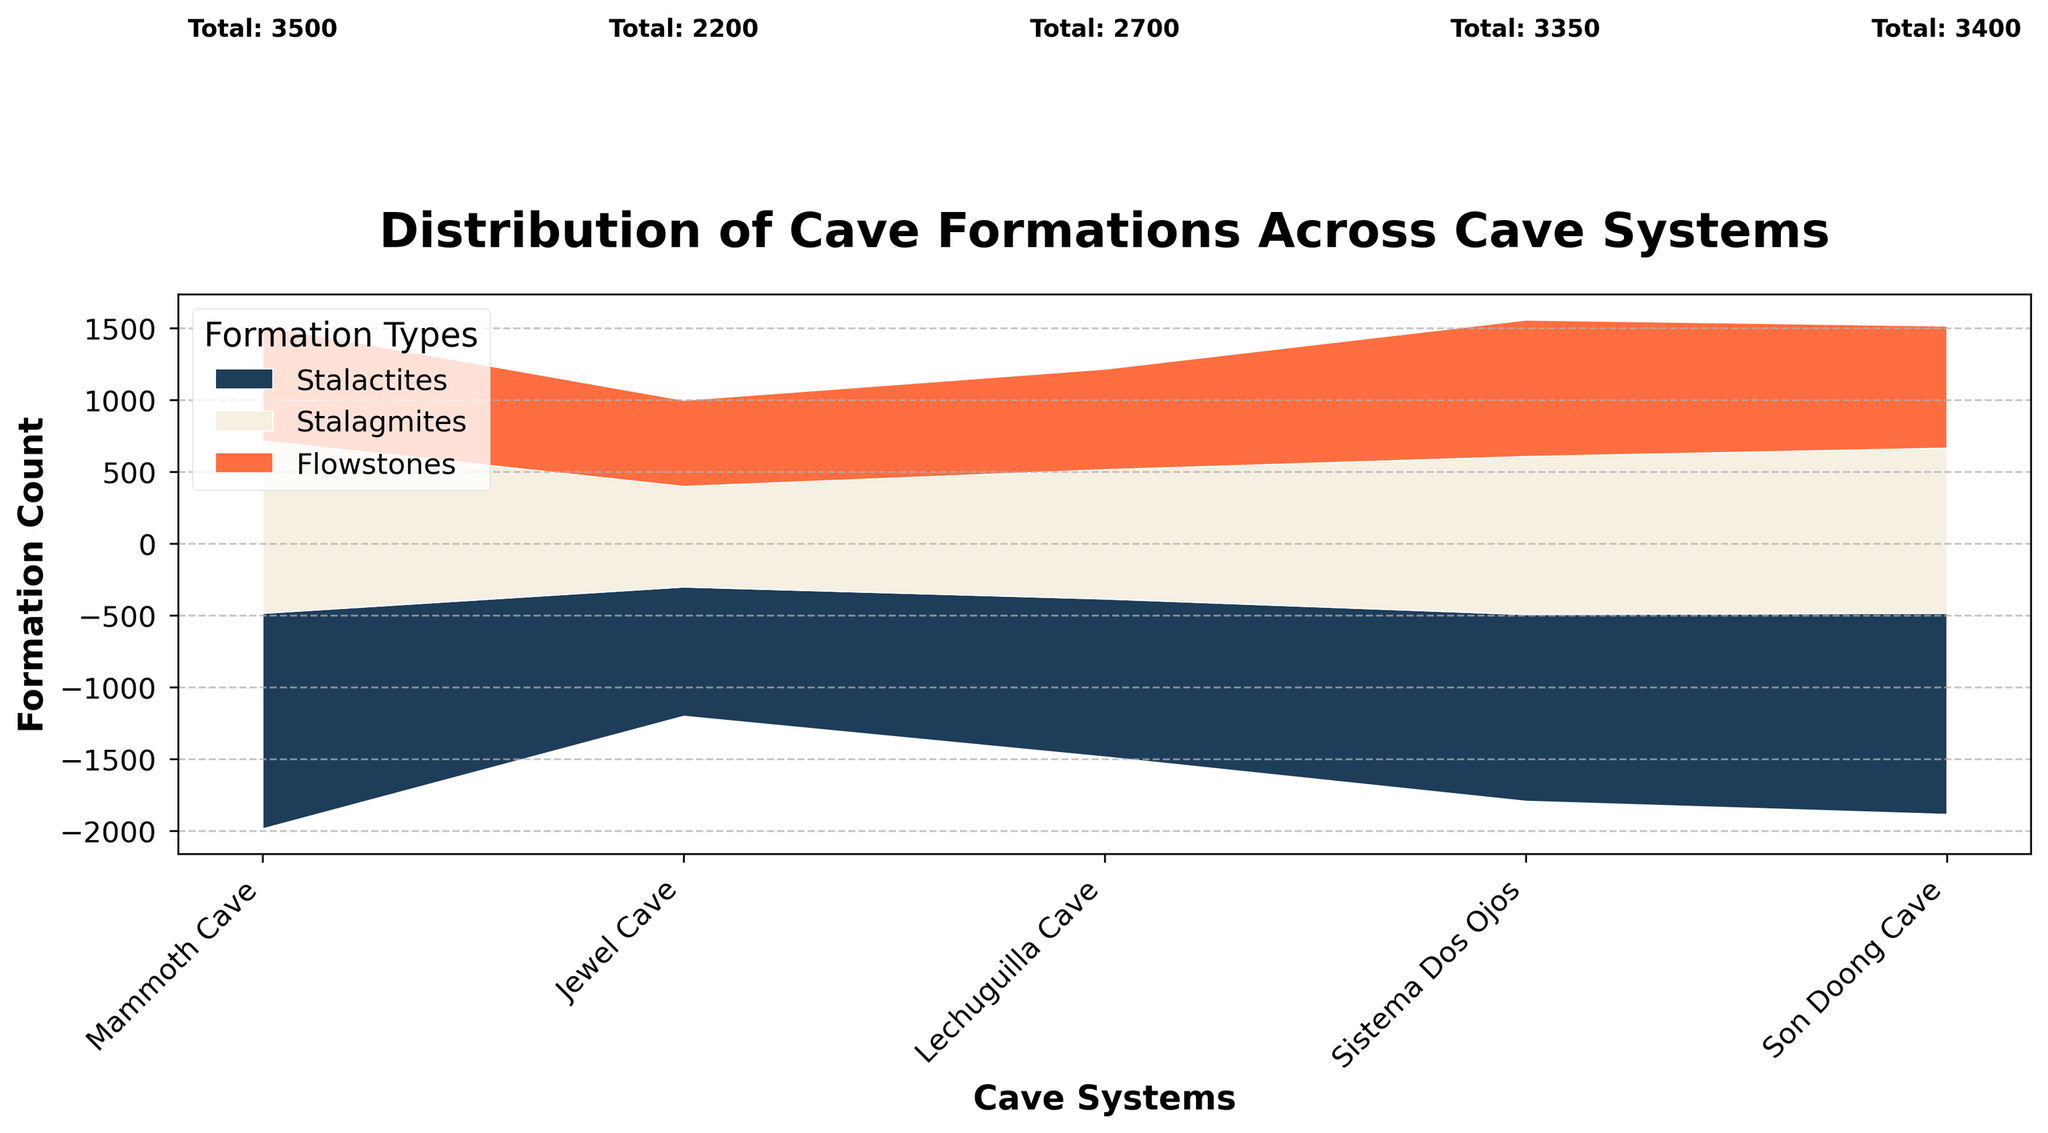What is the title of the plot? The title of the plot is usually found at the top and it describes the main focus of the visual.
Answer: Distribution of Cave Formations Across Cave Systems What are the cave systems included in the plot? The x-axis typically lists the cave systems being analyzed.
Answer: Mammoth Cave, Jewel Cave, Lechuguilla Cave, Sistema Dos Ojos, Son Doong Cave What type of cave formation is the most common in Jewel Cave in 2023? By visually appraising the colored layers in Jewel Cave's section, the layer representing Stalactites seems to be the thickest, which indicates the highest count.
Answer: Stalactites Which cave system has the highest count of Flowstones? By observing the height and size of the Flowstones section (in the corresponding color) for each cave system, Sistema Dos Ojos shows the highest count.
Answer: Sistema Dos Ojos How many total formations are there in Mammoth Cave? The plot includes text annotations for total formations per cave system.
Answer: 3,500 How does the count of Stalactites compare between Mammoth Cave and Lechuguilla Cave? Compare the heights (counts) of the Stalactite segments for Mammoth Cave and Lechuguilla Cave.
Answer: Mammoth Cave has more Stalactites What is the sum of Stalagmites and Flowstones in Son Doong Cave? Identify the respective counts for Stalagmites and Flowstones in Son Doong Cave, then sum these values (1150 + 850).
Answer: 2,000 Which cave system has the least number of total formations? By observing the text annotations for total formations for all cave systems, Jewel Cave has the lowest number.
Answer: Jewel Cave Is there any cave system where the count of Stalactites is equal to the combined count of Flowstones and Stalagmites? Check the counts of each type for each cave system. None of the systems satisfy this condition.
Answer: No 